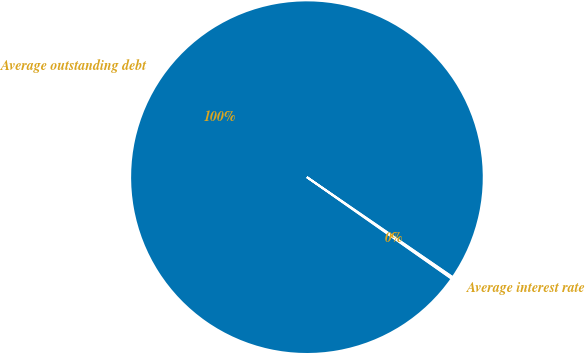Convert chart to OTSL. <chart><loc_0><loc_0><loc_500><loc_500><pie_chart><fcel>Average outstanding debt<fcel>Average interest rate<nl><fcel>99.83%<fcel>0.17%<nl></chart> 